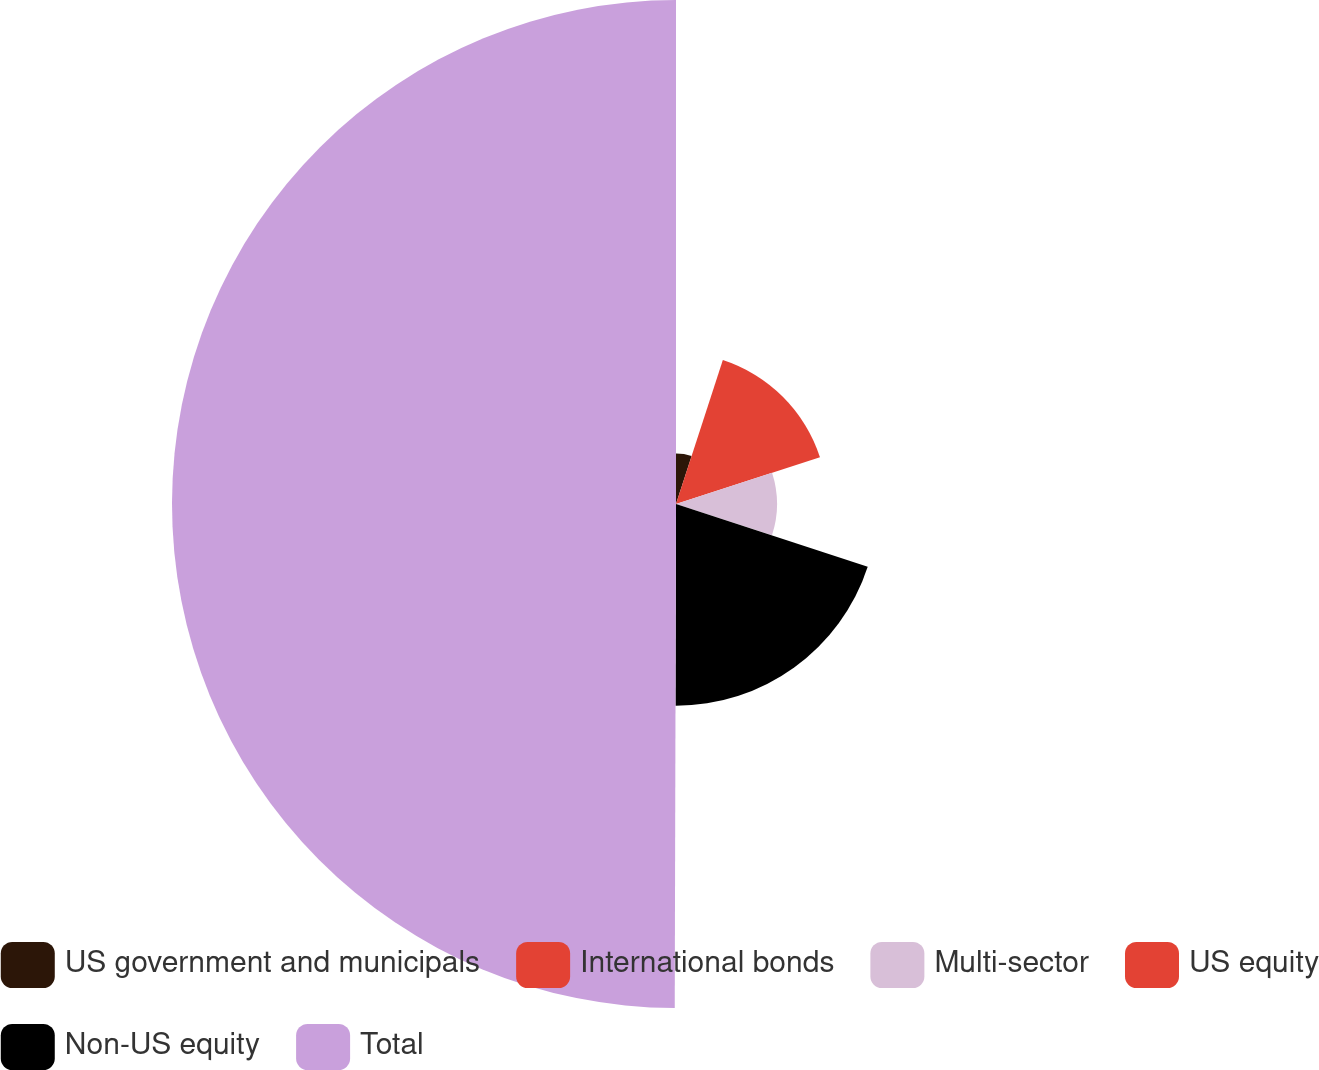Convert chart. <chart><loc_0><loc_0><loc_500><loc_500><pie_chart><fcel>US government and municipals<fcel>International bonds<fcel>Multi-sector<fcel>US equity<fcel>Non-US equity<fcel>Total<nl><fcel>5.01%<fcel>15.0%<fcel>10.01%<fcel>0.02%<fcel>20.0%<fcel>49.96%<nl></chart> 